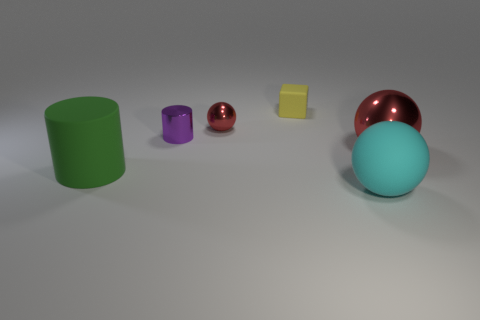What shape is the tiny object that is the same material as the small cylinder?
Make the answer very short. Sphere. What number of large rubber cylinders have the same color as the tiny metallic cylinder?
Your answer should be very brief. 0. What number of things are either brown rubber balls or large spheres?
Your response must be concise. 2. What material is the small yellow block behind the big object that is to the left of the cyan rubber object?
Provide a short and direct response. Rubber. Is there a large green sphere that has the same material as the large green cylinder?
Provide a succinct answer. No. What shape is the red object that is behind the red sphere that is in front of the red ball on the left side of the block?
Your response must be concise. Sphere. What material is the cube?
Offer a very short reply. Rubber. What color is the cube that is made of the same material as the cyan ball?
Offer a very short reply. Yellow. Is there a large ball that is behind the object that is to the right of the big rubber ball?
Your response must be concise. No. How many other things are the same shape as the yellow rubber object?
Provide a succinct answer. 0. 